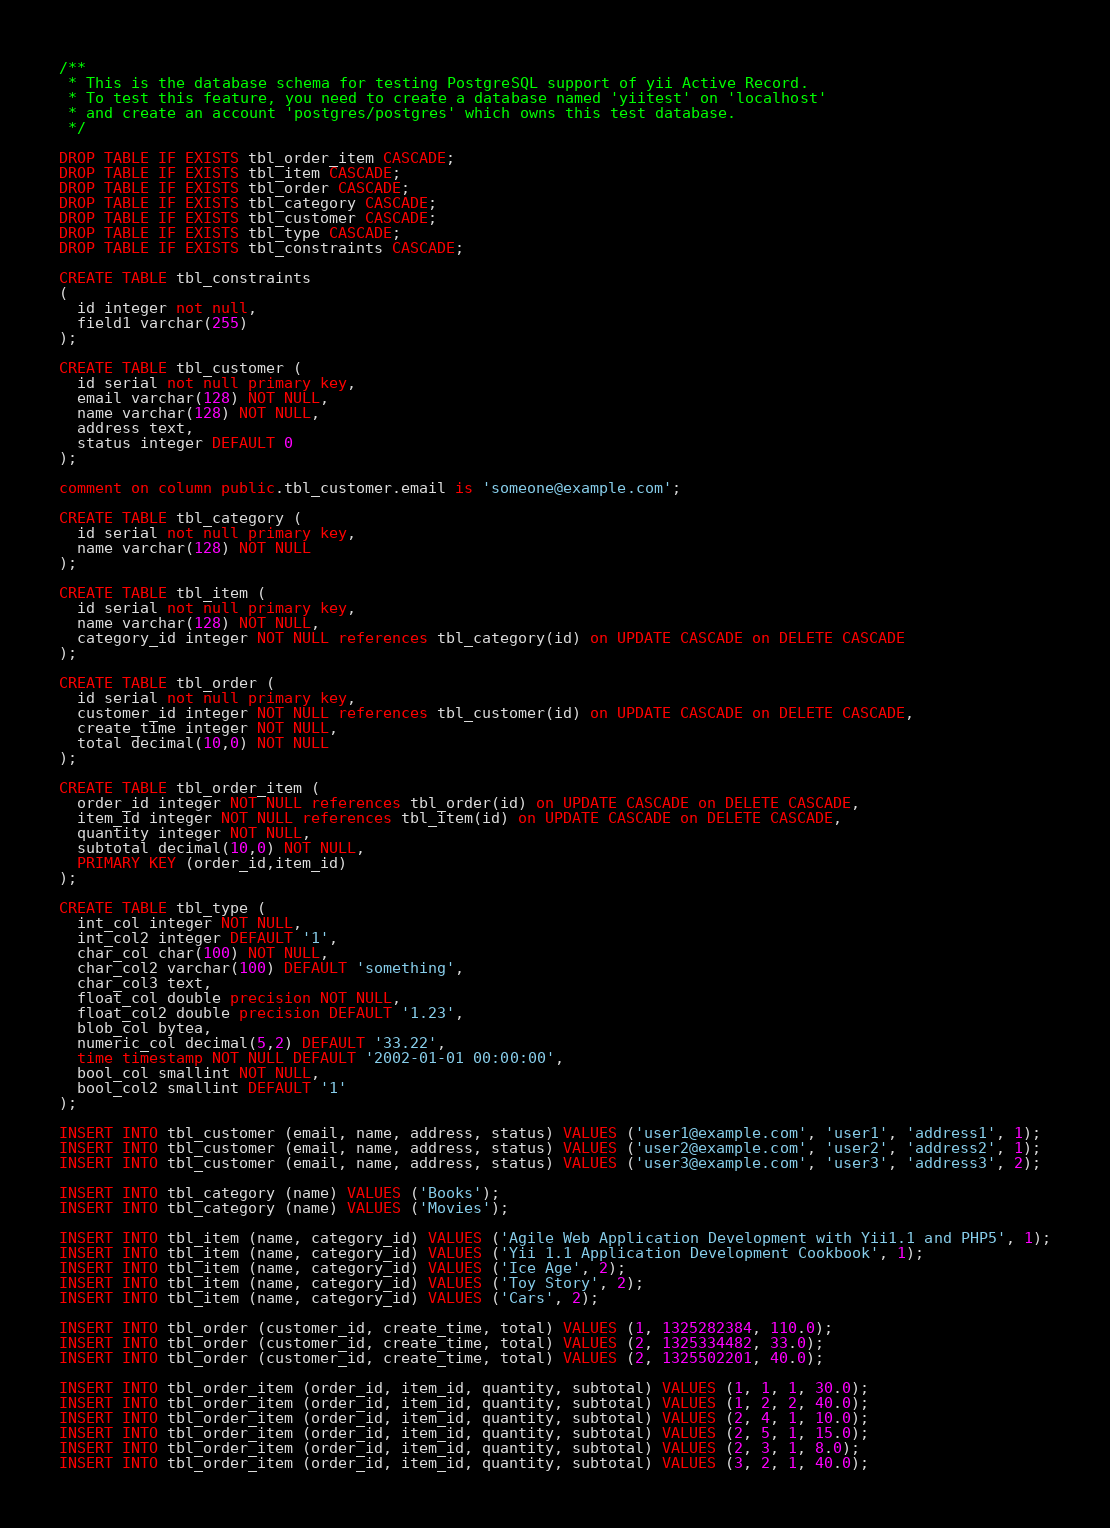<code> <loc_0><loc_0><loc_500><loc_500><_SQL_>/**
 * This is the database schema for testing PostgreSQL support of yii Active Record.
 * To test this feature, you need to create a database named 'yiitest' on 'localhost'
 * and create an account 'postgres/postgres' which owns this test database.
 */

DROP TABLE IF EXISTS tbl_order_item CASCADE;
DROP TABLE IF EXISTS tbl_item CASCADE;
DROP TABLE IF EXISTS tbl_order CASCADE;
DROP TABLE IF EXISTS tbl_category CASCADE;
DROP TABLE IF EXISTS tbl_customer CASCADE;
DROP TABLE IF EXISTS tbl_type CASCADE;
DROP TABLE IF EXISTS tbl_constraints CASCADE;

CREATE TABLE tbl_constraints
(
  id integer not null,
  field1 varchar(255)
);

CREATE TABLE tbl_customer (
  id serial not null primary key,
  email varchar(128) NOT NULL,
  name varchar(128) NOT NULL,
  address text,
  status integer DEFAULT 0
);

comment on column public.tbl_customer.email is 'someone@example.com';

CREATE TABLE tbl_category (
  id serial not null primary key,
  name varchar(128) NOT NULL
);

CREATE TABLE tbl_item (
  id serial not null primary key,
  name varchar(128) NOT NULL,
  category_id integer NOT NULL references tbl_category(id) on UPDATE CASCADE on DELETE CASCADE
);

CREATE TABLE tbl_order (
  id serial not null primary key,
  customer_id integer NOT NULL references tbl_customer(id) on UPDATE CASCADE on DELETE CASCADE,
  create_time integer NOT NULL,
  total decimal(10,0) NOT NULL
);

CREATE TABLE tbl_order_item (
  order_id integer NOT NULL references tbl_order(id) on UPDATE CASCADE on DELETE CASCADE,
  item_id integer NOT NULL references tbl_item(id) on UPDATE CASCADE on DELETE CASCADE,
  quantity integer NOT NULL,
  subtotal decimal(10,0) NOT NULL,
  PRIMARY KEY (order_id,item_id)
);

CREATE TABLE tbl_type (
  int_col integer NOT NULL,
  int_col2 integer DEFAULT '1',
  char_col char(100) NOT NULL,
  char_col2 varchar(100) DEFAULT 'something',
  char_col3 text,
  float_col double precision NOT NULL,
  float_col2 double precision DEFAULT '1.23',
  blob_col bytea,
  numeric_col decimal(5,2) DEFAULT '33.22',
  time timestamp NOT NULL DEFAULT '2002-01-01 00:00:00',
  bool_col smallint NOT NULL,
  bool_col2 smallint DEFAULT '1'
);

INSERT INTO tbl_customer (email, name, address, status) VALUES ('user1@example.com', 'user1', 'address1', 1);
INSERT INTO tbl_customer (email, name, address, status) VALUES ('user2@example.com', 'user2', 'address2', 1);
INSERT INTO tbl_customer (email, name, address, status) VALUES ('user3@example.com', 'user3', 'address3', 2);

INSERT INTO tbl_category (name) VALUES ('Books');
INSERT INTO tbl_category (name) VALUES ('Movies');

INSERT INTO tbl_item (name, category_id) VALUES ('Agile Web Application Development with Yii1.1 and PHP5', 1);
INSERT INTO tbl_item (name, category_id) VALUES ('Yii 1.1 Application Development Cookbook', 1);
INSERT INTO tbl_item (name, category_id) VALUES ('Ice Age', 2);
INSERT INTO tbl_item (name, category_id) VALUES ('Toy Story', 2);
INSERT INTO tbl_item (name, category_id) VALUES ('Cars', 2);

INSERT INTO tbl_order (customer_id, create_time, total) VALUES (1, 1325282384, 110.0);
INSERT INTO tbl_order (customer_id, create_time, total) VALUES (2, 1325334482, 33.0);
INSERT INTO tbl_order (customer_id, create_time, total) VALUES (2, 1325502201, 40.0);

INSERT INTO tbl_order_item (order_id, item_id, quantity, subtotal) VALUES (1, 1, 1, 30.0);
INSERT INTO tbl_order_item (order_id, item_id, quantity, subtotal) VALUES (1, 2, 2, 40.0);
INSERT INTO tbl_order_item (order_id, item_id, quantity, subtotal) VALUES (2, 4, 1, 10.0);
INSERT INTO tbl_order_item (order_id, item_id, quantity, subtotal) VALUES (2, 5, 1, 15.0);
INSERT INTO tbl_order_item (order_id, item_id, quantity, subtotal) VALUES (2, 3, 1, 8.0);
INSERT INTO tbl_order_item (order_id, item_id, quantity, subtotal) VALUES (3, 2, 1, 40.0);
</code> 